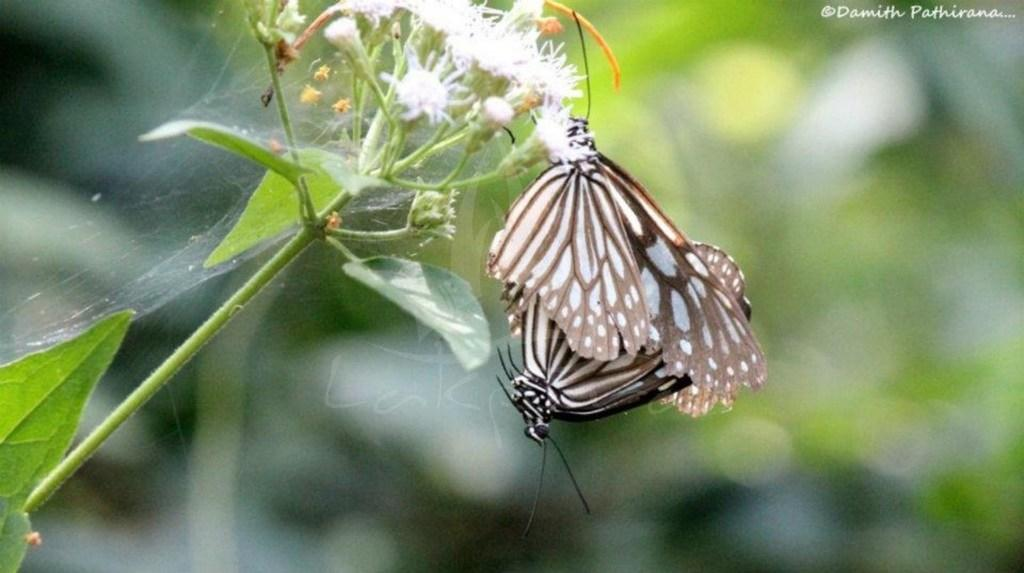What type of insects can be seen in the image? There are butterflies on a flower in the image. What other plant elements are visible in the image? There are leaves in the image. Can you describe the structure that connects the flower to the leaves? There is a stem in the image. What type of spoon can be seen in the image? There is no spoon present in the image. How does the rod in the image move? There is no rod present in the image, so it cannot be determined how it might move. 